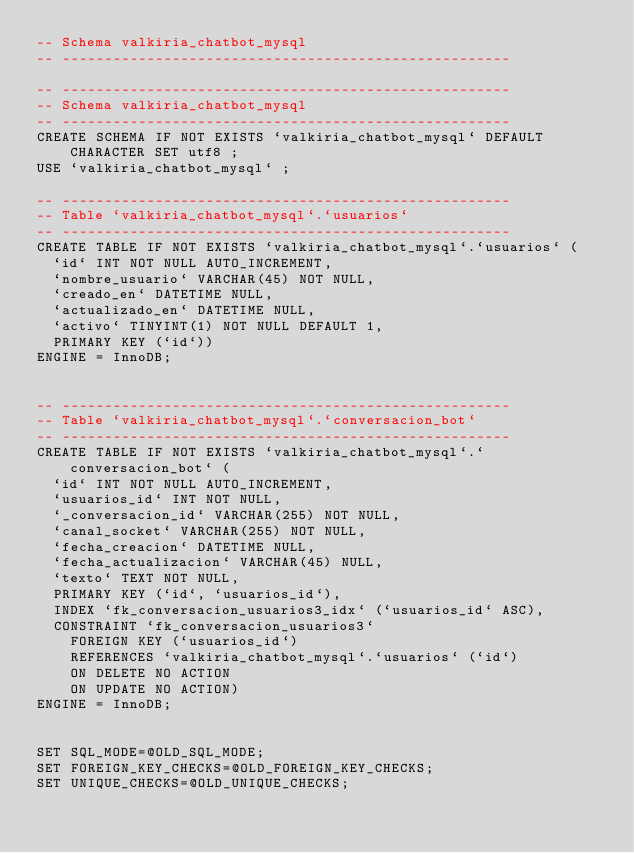<code> <loc_0><loc_0><loc_500><loc_500><_SQL_>-- Schema valkiria_chatbot_mysql
-- -----------------------------------------------------

-- -----------------------------------------------------
-- Schema valkiria_chatbot_mysql
-- -----------------------------------------------------
CREATE SCHEMA IF NOT EXISTS `valkiria_chatbot_mysql` DEFAULT CHARACTER SET utf8 ;
USE `valkiria_chatbot_mysql` ;

-- -----------------------------------------------------
-- Table `valkiria_chatbot_mysql`.`usuarios`
-- -----------------------------------------------------
CREATE TABLE IF NOT EXISTS `valkiria_chatbot_mysql`.`usuarios` (
  `id` INT NOT NULL AUTO_INCREMENT,
  `nombre_usuario` VARCHAR(45) NOT NULL,
  `creado_en` DATETIME NULL,
  `actualizado_en` DATETIME NULL,
  `activo` TINYINT(1) NOT NULL DEFAULT 1,
  PRIMARY KEY (`id`))
ENGINE = InnoDB;


-- -----------------------------------------------------
-- Table `valkiria_chatbot_mysql`.`conversacion_bot`
-- -----------------------------------------------------
CREATE TABLE IF NOT EXISTS `valkiria_chatbot_mysql`.`conversacion_bot` (
  `id` INT NOT NULL AUTO_INCREMENT,
  `usuarios_id` INT NOT NULL,
  `_conversacion_id` VARCHAR(255) NOT NULL,
  `canal_socket` VARCHAR(255) NOT NULL,
  `fecha_creacion` DATETIME NULL,
  `fecha_actualizacion` VARCHAR(45) NULL,
  `texto` TEXT NOT NULL,
  PRIMARY KEY (`id`, `usuarios_id`),
  INDEX `fk_conversacion_usuarios3_idx` (`usuarios_id` ASC),
  CONSTRAINT `fk_conversacion_usuarios3`
    FOREIGN KEY (`usuarios_id`)
    REFERENCES `valkiria_chatbot_mysql`.`usuarios` (`id`)
    ON DELETE NO ACTION
    ON UPDATE NO ACTION)
ENGINE = InnoDB;


SET SQL_MODE=@OLD_SQL_MODE;
SET FOREIGN_KEY_CHECKS=@OLD_FOREIGN_KEY_CHECKS;
SET UNIQUE_CHECKS=@OLD_UNIQUE_CHECKS;
</code> 